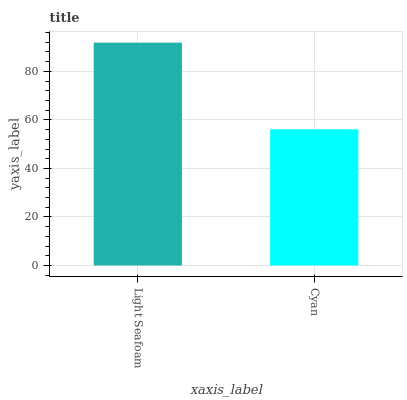Is Cyan the minimum?
Answer yes or no. Yes. Is Light Seafoam the maximum?
Answer yes or no. Yes. Is Cyan the maximum?
Answer yes or no. No. Is Light Seafoam greater than Cyan?
Answer yes or no. Yes. Is Cyan less than Light Seafoam?
Answer yes or no. Yes. Is Cyan greater than Light Seafoam?
Answer yes or no. No. Is Light Seafoam less than Cyan?
Answer yes or no. No. Is Light Seafoam the high median?
Answer yes or no. Yes. Is Cyan the low median?
Answer yes or no. Yes. Is Cyan the high median?
Answer yes or no. No. Is Light Seafoam the low median?
Answer yes or no. No. 